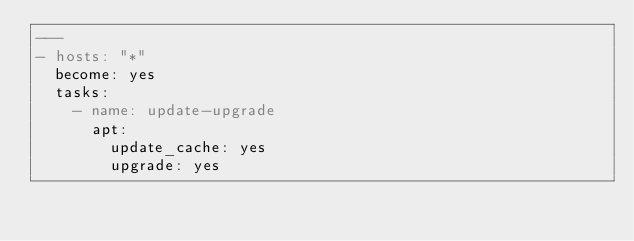<code> <loc_0><loc_0><loc_500><loc_500><_YAML_>---
- hosts: "*"
  become: yes
  tasks:
    - name: update-upgrade
      apt:
        update_cache: yes
        upgrade: yes</code> 